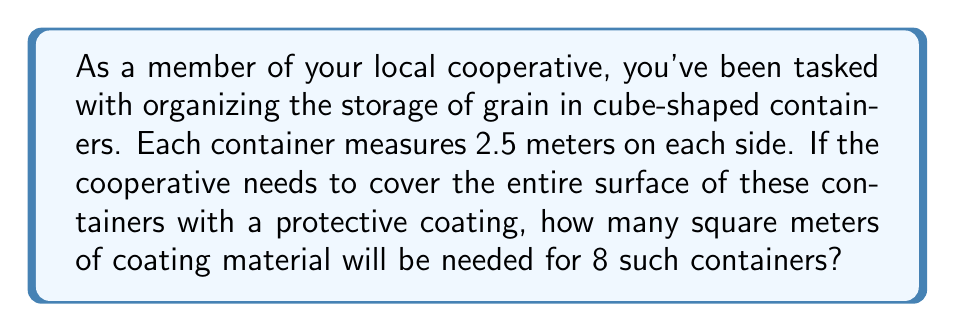Help me with this question. Let's approach this step-by-step:

1) First, we need to calculate the surface area of a single cube-shaped container.
   The formula for the surface area of a cube is:
   
   $$ SA = 6s^2 $$
   
   where $SA$ is the surface area and $s$ is the length of one side.

2) We're given that each side measures 2.5 meters. Let's substitute this into our formula:

   $$ SA = 6 * (2.5\text{ m})^2 $$

3) Let's calculate:
   $$ SA = 6 * 6.25\text{ m}^2 = 37.5\text{ m}^2 $$

4) So each container requires 37.5 square meters of coating.

5) We need to coat 8 such containers. To find the total area, we multiply:

   $$ \text{Total Area} = 8 * 37.5\text{ m}^2 = 300\text{ m}^2 $$

Therefore, the cooperative will need 300 square meters of coating material for 8 containers.
Answer: 300 m² 